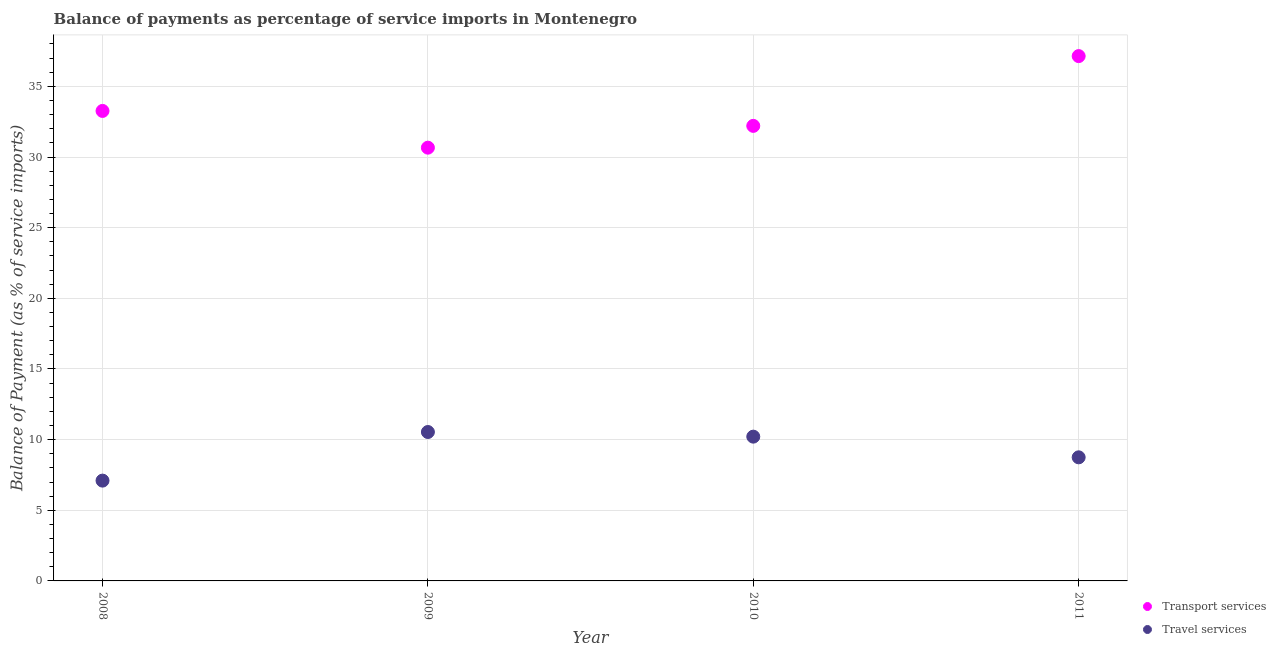Is the number of dotlines equal to the number of legend labels?
Provide a succinct answer. Yes. What is the balance of payments of travel services in 2008?
Offer a very short reply. 7.1. Across all years, what is the maximum balance of payments of transport services?
Your answer should be very brief. 37.14. Across all years, what is the minimum balance of payments of transport services?
Provide a short and direct response. 30.66. In which year was the balance of payments of transport services minimum?
Offer a very short reply. 2009. What is the total balance of payments of transport services in the graph?
Your answer should be very brief. 133.27. What is the difference between the balance of payments of travel services in 2009 and that in 2010?
Offer a very short reply. 0.33. What is the difference between the balance of payments of transport services in 2010 and the balance of payments of travel services in 2009?
Your answer should be compact. 21.67. What is the average balance of payments of travel services per year?
Offer a very short reply. 9.15. In the year 2008, what is the difference between the balance of payments of transport services and balance of payments of travel services?
Keep it short and to the point. 26.16. What is the ratio of the balance of payments of travel services in 2008 to that in 2009?
Provide a succinct answer. 0.67. Is the balance of payments of travel services in 2009 less than that in 2011?
Provide a succinct answer. No. Is the difference between the balance of payments of travel services in 2008 and 2009 greater than the difference between the balance of payments of transport services in 2008 and 2009?
Your answer should be compact. No. What is the difference between the highest and the second highest balance of payments of transport services?
Keep it short and to the point. 3.88. What is the difference between the highest and the lowest balance of payments of travel services?
Your response must be concise. 3.44. In how many years, is the balance of payments of transport services greater than the average balance of payments of transport services taken over all years?
Provide a short and direct response. 1. How many dotlines are there?
Your answer should be very brief. 2. How many years are there in the graph?
Your answer should be compact. 4. What is the difference between two consecutive major ticks on the Y-axis?
Keep it short and to the point. 5. Does the graph contain grids?
Offer a terse response. Yes. Where does the legend appear in the graph?
Your answer should be compact. Bottom right. How many legend labels are there?
Provide a succinct answer. 2. What is the title of the graph?
Your answer should be compact. Balance of payments as percentage of service imports in Montenegro. Does "Manufacturing industries and construction" appear as one of the legend labels in the graph?
Give a very brief answer. No. What is the label or title of the X-axis?
Keep it short and to the point. Year. What is the label or title of the Y-axis?
Offer a very short reply. Balance of Payment (as % of service imports). What is the Balance of Payment (as % of service imports) of Transport services in 2008?
Provide a succinct answer. 33.26. What is the Balance of Payment (as % of service imports) of Travel services in 2008?
Offer a very short reply. 7.1. What is the Balance of Payment (as % of service imports) of Transport services in 2009?
Your answer should be compact. 30.66. What is the Balance of Payment (as % of service imports) of Travel services in 2009?
Give a very brief answer. 10.54. What is the Balance of Payment (as % of service imports) in Transport services in 2010?
Ensure brevity in your answer.  32.2. What is the Balance of Payment (as % of service imports) of Travel services in 2010?
Offer a terse response. 10.21. What is the Balance of Payment (as % of service imports) of Transport services in 2011?
Keep it short and to the point. 37.14. What is the Balance of Payment (as % of service imports) in Travel services in 2011?
Offer a very short reply. 8.75. Across all years, what is the maximum Balance of Payment (as % of service imports) in Transport services?
Provide a succinct answer. 37.14. Across all years, what is the maximum Balance of Payment (as % of service imports) of Travel services?
Make the answer very short. 10.54. Across all years, what is the minimum Balance of Payment (as % of service imports) of Transport services?
Offer a terse response. 30.66. Across all years, what is the minimum Balance of Payment (as % of service imports) in Travel services?
Offer a terse response. 7.1. What is the total Balance of Payment (as % of service imports) of Transport services in the graph?
Ensure brevity in your answer.  133.27. What is the total Balance of Payment (as % of service imports) in Travel services in the graph?
Offer a very short reply. 36.59. What is the difference between the Balance of Payment (as % of service imports) of Transport services in 2008 and that in 2009?
Your response must be concise. 2.6. What is the difference between the Balance of Payment (as % of service imports) of Travel services in 2008 and that in 2009?
Offer a very short reply. -3.44. What is the difference between the Balance of Payment (as % of service imports) in Transport services in 2008 and that in 2010?
Your answer should be very brief. 1.06. What is the difference between the Balance of Payment (as % of service imports) of Travel services in 2008 and that in 2010?
Give a very brief answer. -3.11. What is the difference between the Balance of Payment (as % of service imports) of Transport services in 2008 and that in 2011?
Provide a short and direct response. -3.88. What is the difference between the Balance of Payment (as % of service imports) in Travel services in 2008 and that in 2011?
Offer a very short reply. -1.65. What is the difference between the Balance of Payment (as % of service imports) of Transport services in 2009 and that in 2010?
Provide a succinct answer. -1.54. What is the difference between the Balance of Payment (as % of service imports) of Travel services in 2009 and that in 2010?
Provide a succinct answer. 0.33. What is the difference between the Balance of Payment (as % of service imports) of Transport services in 2009 and that in 2011?
Make the answer very short. -6.48. What is the difference between the Balance of Payment (as % of service imports) of Travel services in 2009 and that in 2011?
Make the answer very short. 1.79. What is the difference between the Balance of Payment (as % of service imports) in Transport services in 2010 and that in 2011?
Offer a terse response. -4.94. What is the difference between the Balance of Payment (as % of service imports) of Travel services in 2010 and that in 2011?
Offer a very short reply. 1.46. What is the difference between the Balance of Payment (as % of service imports) in Transport services in 2008 and the Balance of Payment (as % of service imports) in Travel services in 2009?
Make the answer very short. 22.72. What is the difference between the Balance of Payment (as % of service imports) in Transport services in 2008 and the Balance of Payment (as % of service imports) in Travel services in 2010?
Ensure brevity in your answer.  23.05. What is the difference between the Balance of Payment (as % of service imports) in Transport services in 2008 and the Balance of Payment (as % of service imports) in Travel services in 2011?
Provide a succinct answer. 24.51. What is the difference between the Balance of Payment (as % of service imports) in Transport services in 2009 and the Balance of Payment (as % of service imports) in Travel services in 2010?
Make the answer very short. 20.45. What is the difference between the Balance of Payment (as % of service imports) in Transport services in 2009 and the Balance of Payment (as % of service imports) in Travel services in 2011?
Ensure brevity in your answer.  21.91. What is the difference between the Balance of Payment (as % of service imports) of Transport services in 2010 and the Balance of Payment (as % of service imports) of Travel services in 2011?
Your response must be concise. 23.46. What is the average Balance of Payment (as % of service imports) in Transport services per year?
Keep it short and to the point. 33.32. What is the average Balance of Payment (as % of service imports) in Travel services per year?
Offer a very short reply. 9.15. In the year 2008, what is the difference between the Balance of Payment (as % of service imports) of Transport services and Balance of Payment (as % of service imports) of Travel services?
Give a very brief answer. 26.16. In the year 2009, what is the difference between the Balance of Payment (as % of service imports) in Transport services and Balance of Payment (as % of service imports) in Travel services?
Provide a short and direct response. 20.12. In the year 2010, what is the difference between the Balance of Payment (as % of service imports) in Transport services and Balance of Payment (as % of service imports) in Travel services?
Offer a very short reply. 21.99. In the year 2011, what is the difference between the Balance of Payment (as % of service imports) of Transport services and Balance of Payment (as % of service imports) of Travel services?
Offer a terse response. 28.39. What is the ratio of the Balance of Payment (as % of service imports) of Transport services in 2008 to that in 2009?
Your answer should be compact. 1.08. What is the ratio of the Balance of Payment (as % of service imports) of Travel services in 2008 to that in 2009?
Ensure brevity in your answer.  0.67. What is the ratio of the Balance of Payment (as % of service imports) in Transport services in 2008 to that in 2010?
Offer a very short reply. 1.03. What is the ratio of the Balance of Payment (as % of service imports) in Travel services in 2008 to that in 2010?
Keep it short and to the point. 0.7. What is the ratio of the Balance of Payment (as % of service imports) in Transport services in 2008 to that in 2011?
Provide a short and direct response. 0.9. What is the ratio of the Balance of Payment (as % of service imports) of Travel services in 2008 to that in 2011?
Give a very brief answer. 0.81. What is the ratio of the Balance of Payment (as % of service imports) in Transport services in 2009 to that in 2010?
Provide a succinct answer. 0.95. What is the ratio of the Balance of Payment (as % of service imports) of Travel services in 2009 to that in 2010?
Your answer should be compact. 1.03. What is the ratio of the Balance of Payment (as % of service imports) in Transport services in 2009 to that in 2011?
Keep it short and to the point. 0.83. What is the ratio of the Balance of Payment (as % of service imports) in Travel services in 2009 to that in 2011?
Give a very brief answer. 1.2. What is the ratio of the Balance of Payment (as % of service imports) of Transport services in 2010 to that in 2011?
Keep it short and to the point. 0.87. What is the ratio of the Balance of Payment (as % of service imports) in Travel services in 2010 to that in 2011?
Make the answer very short. 1.17. What is the difference between the highest and the second highest Balance of Payment (as % of service imports) of Transport services?
Give a very brief answer. 3.88. What is the difference between the highest and the second highest Balance of Payment (as % of service imports) in Travel services?
Provide a short and direct response. 0.33. What is the difference between the highest and the lowest Balance of Payment (as % of service imports) in Transport services?
Make the answer very short. 6.48. What is the difference between the highest and the lowest Balance of Payment (as % of service imports) of Travel services?
Provide a succinct answer. 3.44. 